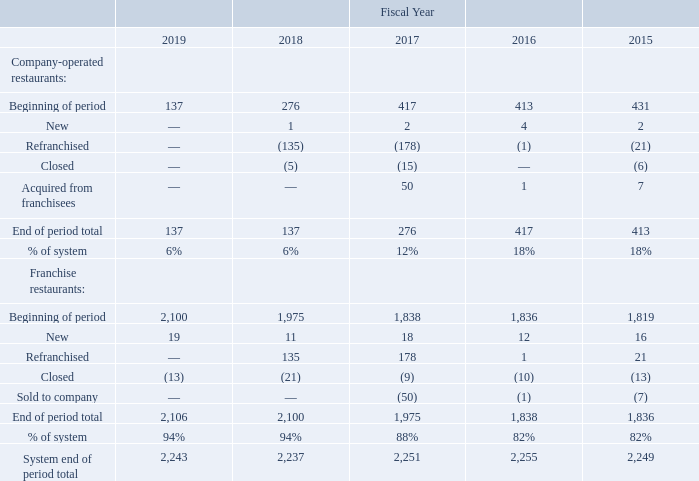Jack in the Box restaurants offer a broad selection of distinctive products including classic burgers like our Jumbo Jack® and innovative product lines such as Buttery Jack® burgers. We also offer quality products such as breakfast sandwiches with freshly cracked eggs, and craveable favorites such as tacos and curly fries, along with specialty sandwiches, salads, and real ice cream shakes, among other items. We allow our guests to customize their meals to their tastes and order any product when they want it, including breakfast items any time of day (or night). We are known for variety and innovation, which has led to the development of four strong dayparts: breakfast, lunch, dinner, and late-night.
The Jack in the Box restaurant chain was the first major hamburger chain to develop and expand the concept of drive-thru restaurants. In addition to drive-thru windows, most of our restaurants have seating capacities ranging from 20 to 100 people and are open 18-24 hours a day. Drive-thru sales currently account for approximately 70% of sales at company-operated restaurants. The average check in fiscal year2019 was $8.34 for company-operated restaurants.
With a presence in only 21 states and one territory, we believe Jack in the Box is a brand with significant growth opportunities. In fiscal 2019, franchisees continued to expand in existing markets.
The following table summarizes the changes in the number of company-operated and franchise restaurants over the past five years:
Site selections for all new company-operated restaurants are made after an economic analysis and a review of demographic data and other information relating to population density, traffic, competition, restaurant visibility and access, available parking, surrounding businesses, and opportunities for market penetration. Restaurants developed by franchisees are built to brand specifications on sites we have approved.
Our company-operated restaurants have multiple restaurant models with different seating capacities to improve our flexibility in selecting locations. Management believes that this flexibility enables the Company to match the restaurant configuration with the specific economic, demographic, geographic, or physical characteristics of a particular site.
Typical costs to develop a traditional restaurant, excluding the land value, range from approximately$1.4 million to $2.0 million. The majority of our corporate restaurants are constructed on leased land or on land that we purchase and subsequently sell, along with the improvements, in sale and leaseback transactions. Upon completion of a sale and leaseback transaction, the Company’s initial cash investment is reduced to the cost of equipment, which ranges from approximately $0.4 million to $0.5 million.
What was the average check for comapny-operated restaurants in fiscal year 2019? $8.34. What percentage of sales at company-operated restaurants are from drive-thru sales? Approximately 70%. For company-operated restaurants, what is the end of period total in fiscal year 2019? 137. What is the difference in the number of company-operated restaurants between 2017 and 2018 at end of period total?  276 - 137 
Answer: 139. For franchise restaurants, what is the average end of period total for 2018 and 2019? (2,106 + 2,100)/2 
Answer: 2103. For franchise restaurants, what is the percentage increase of end of period total from 2015 to 2016?
Answer scale should be: percent. (1,838 - 1,836)/ 1,836 
Answer: 0.11. 